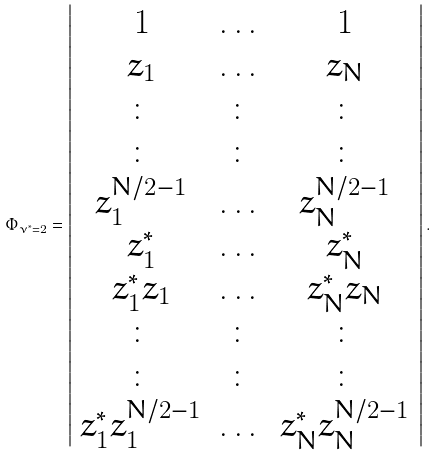<formula> <loc_0><loc_0><loc_500><loc_500>\Phi _ { \nu ^ { * } = 2 } = \left | \begin{array} { c c c } 1 & \dots & 1 \\ z _ { 1 } & \dots & z _ { N } \\ \colon & \colon & \colon \\ \colon & \colon & \colon \\ z _ { 1 } ^ { N / 2 - 1 } & \dots & z _ { N } ^ { N / 2 - 1 } \\ z ^ { * } _ { 1 } & \dots & z ^ { * } _ { N } \\ z ^ { * } _ { 1 } z _ { 1 } & \dots & z ^ { * } _ { N } z _ { N } \\ \colon & \colon & \colon \\ \colon & \colon & \colon \\ z ^ { * } _ { 1 } z _ { 1 } ^ { N / 2 - 1 } & \dots & z ^ { * } _ { N } z _ { N } ^ { N / 2 - 1 } \end{array} \right | .</formula> 